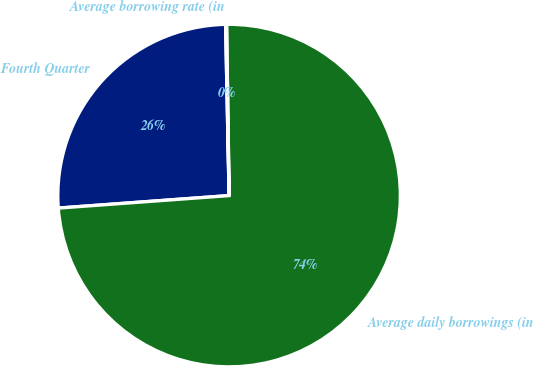<chart> <loc_0><loc_0><loc_500><loc_500><pie_chart><fcel>Fourth Quarter<fcel>Average daily borrowings (in<fcel>Average borrowing rate (in<nl><fcel>25.84%<fcel>74.07%<fcel>0.09%<nl></chart> 